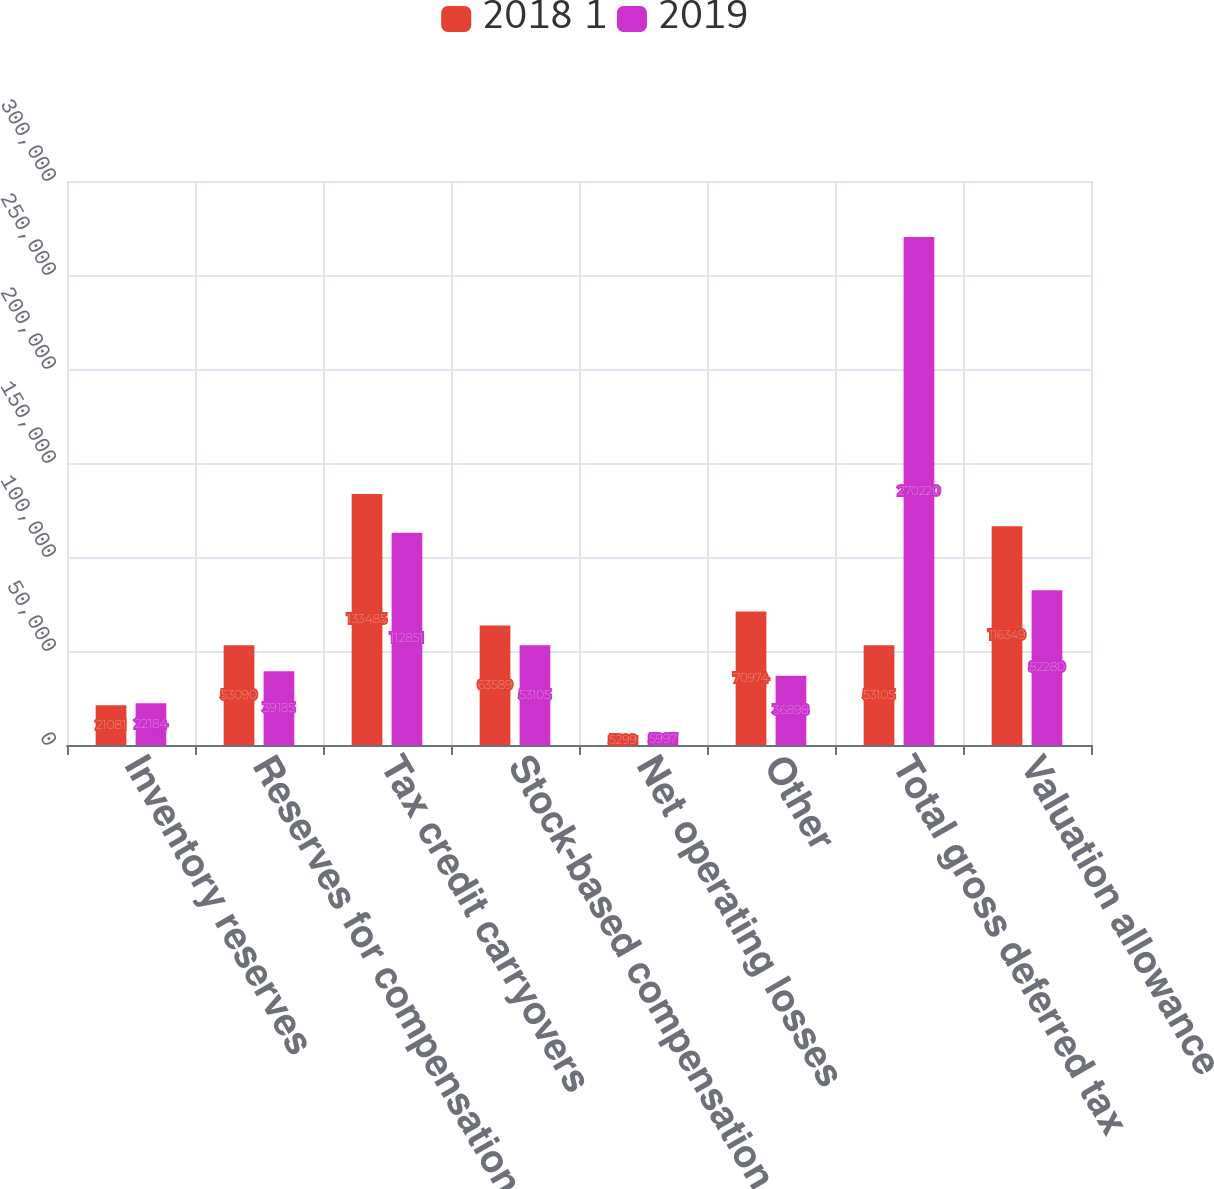Convert chart. <chart><loc_0><loc_0><loc_500><loc_500><stacked_bar_chart><ecel><fcel>Inventory reserves<fcel>Reserves for compensation and<fcel>Tax credit carryovers<fcel>Stock-based compensation<fcel>Net operating losses<fcel>Other<fcel>Total gross deferred tax<fcel>Valuation allowance<nl><fcel>2018 1<fcel>21081<fcel>53090<fcel>133485<fcel>63589<fcel>5299<fcel>70974<fcel>53105<fcel>116349<nl><fcel>2019<fcel>22184<fcel>39185<fcel>112851<fcel>53105<fcel>5997<fcel>36898<fcel>270220<fcel>82280<nl></chart> 